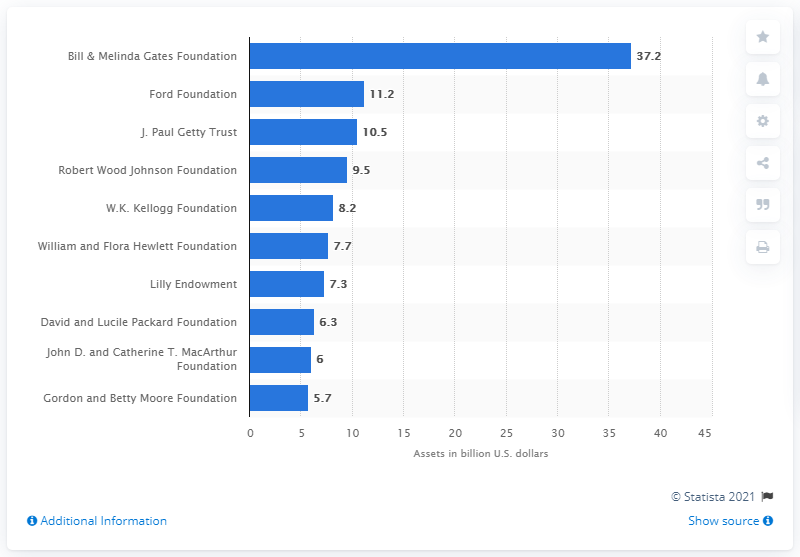Specify some key components in this picture. The Bill and Melinda Gates Foundation's total assets in 2013 were 37.2 billion dollars. 